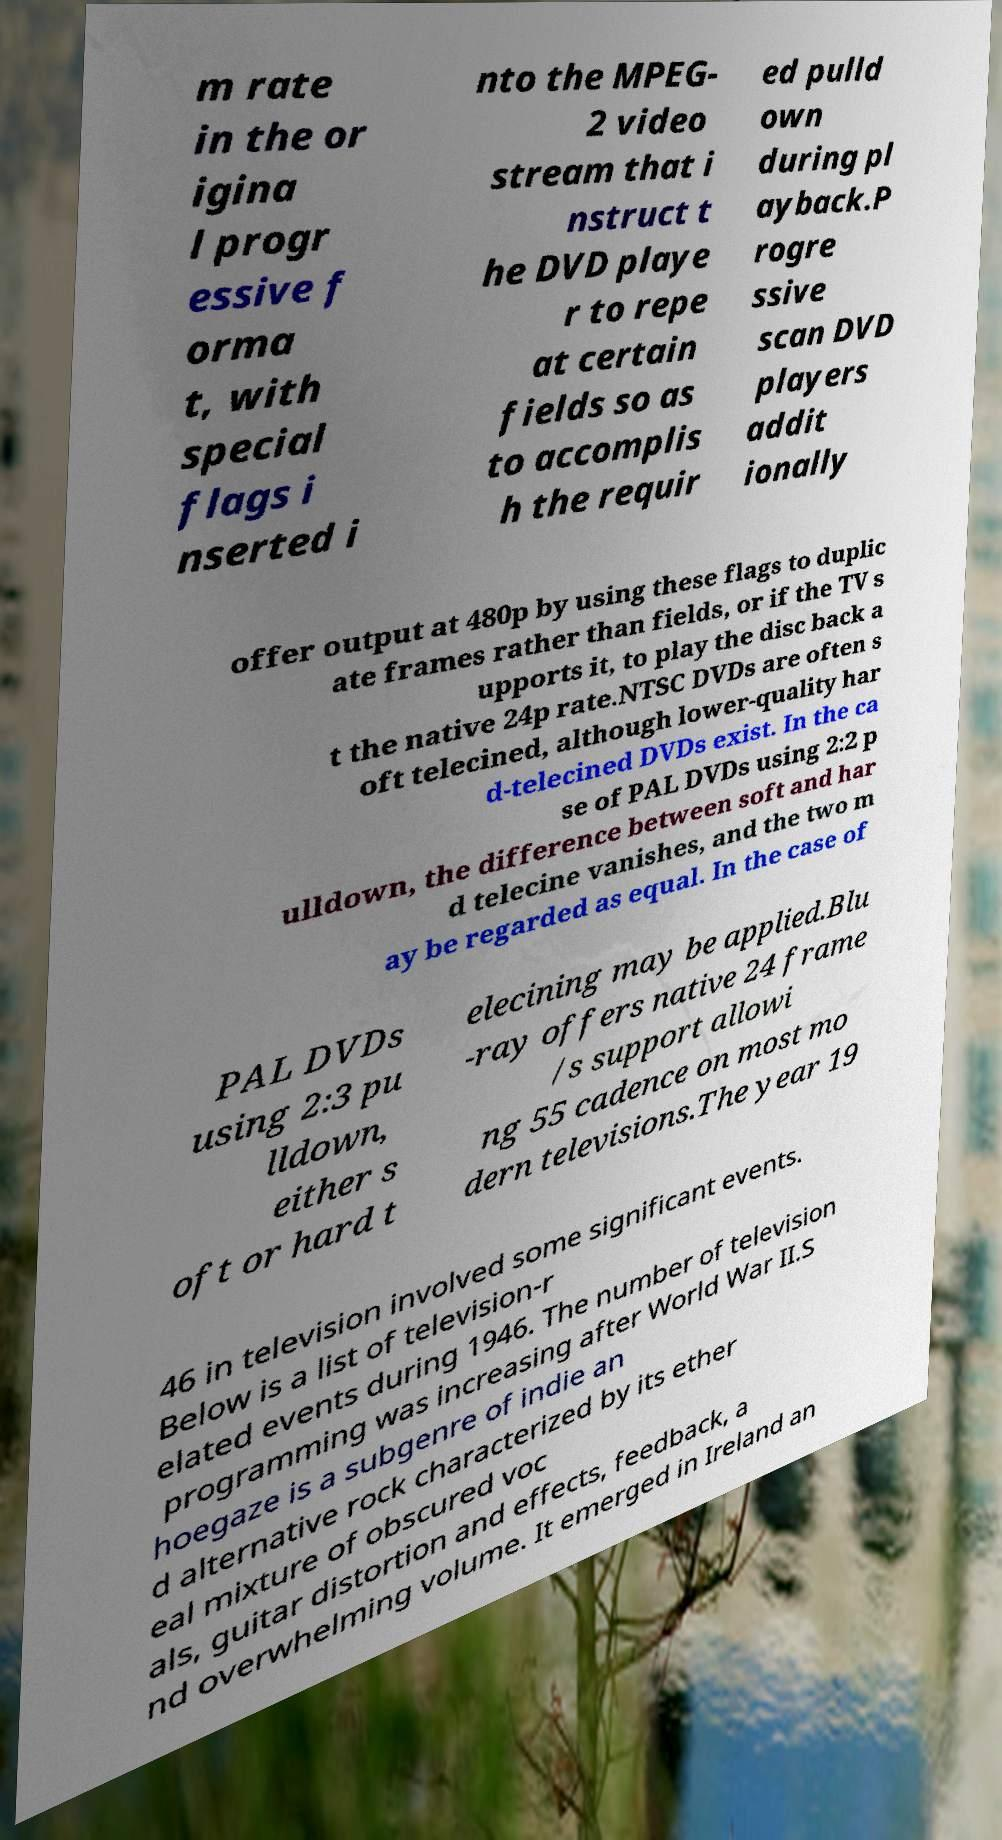I need the written content from this picture converted into text. Can you do that? m rate in the or igina l progr essive f orma t, with special flags i nserted i nto the MPEG- 2 video stream that i nstruct t he DVD playe r to repe at certain fields so as to accomplis h the requir ed pulld own during pl ayback.P rogre ssive scan DVD players addit ionally offer output at 480p by using these flags to duplic ate frames rather than fields, or if the TV s upports it, to play the disc back a t the native 24p rate.NTSC DVDs are often s oft telecined, although lower-quality har d-telecined DVDs exist. In the ca se of PAL DVDs using 2:2 p ulldown, the difference between soft and har d telecine vanishes, and the two m ay be regarded as equal. In the case of PAL DVDs using 2:3 pu lldown, either s oft or hard t elecining may be applied.Blu -ray offers native 24 frame /s support allowi ng 55 cadence on most mo dern televisions.The year 19 46 in television involved some significant events. Below is a list of television-r elated events during 1946. The number of television programming was increasing after World War II.S hoegaze is a subgenre of indie an d alternative rock characterized by its ether eal mixture of obscured voc als, guitar distortion and effects, feedback, a nd overwhelming volume. It emerged in Ireland an 